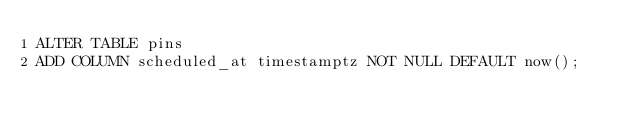Convert code to text. <code><loc_0><loc_0><loc_500><loc_500><_SQL_>ALTER TABLE pins
ADD COLUMN scheduled_at timestamptz NOT NULL DEFAULT now();
</code> 